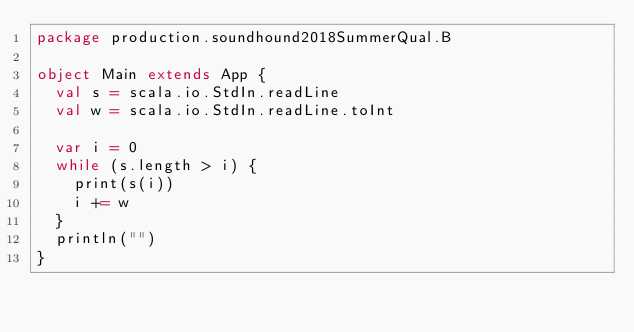<code> <loc_0><loc_0><loc_500><loc_500><_Scala_>package production.soundhound2018SummerQual.B

object Main extends App {
  val s = scala.io.StdIn.readLine
  val w = scala.io.StdIn.readLine.toInt

  var i = 0
  while (s.length > i) {
    print(s(i))
    i += w
  }
  println("")
}
</code> 